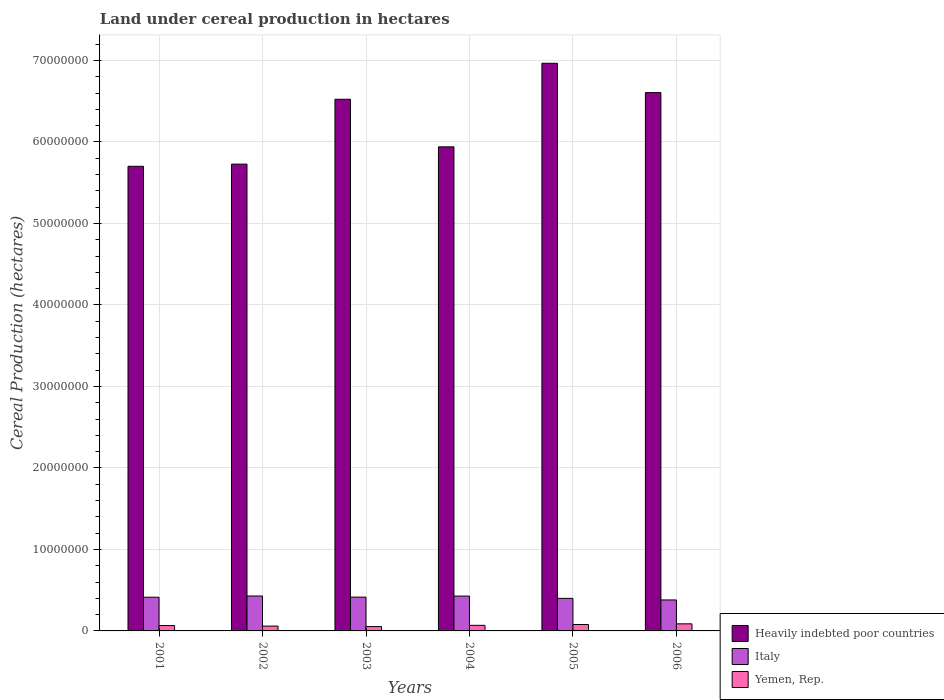How many different coloured bars are there?
Give a very brief answer. 3. What is the label of the 6th group of bars from the left?
Give a very brief answer. 2006. In how many cases, is the number of bars for a given year not equal to the number of legend labels?
Your response must be concise. 0. What is the land under cereal production in Italy in 2004?
Your answer should be compact. 4.28e+06. Across all years, what is the maximum land under cereal production in Italy?
Your response must be concise. 4.28e+06. Across all years, what is the minimum land under cereal production in Yemen, Rep.?
Offer a very short reply. 5.32e+05. What is the total land under cereal production in Italy in the graph?
Your answer should be very brief. 2.46e+07. What is the difference between the land under cereal production in Italy in 2002 and that in 2005?
Provide a succinct answer. 2.89e+05. What is the difference between the land under cereal production in Yemen, Rep. in 2001 and the land under cereal production in Heavily indebted poor countries in 2002?
Offer a terse response. -5.66e+07. What is the average land under cereal production in Yemen, Rep. per year?
Ensure brevity in your answer.  6.88e+05. In the year 2003, what is the difference between the land under cereal production in Yemen, Rep. and land under cereal production in Italy?
Your response must be concise. -3.62e+06. What is the ratio of the land under cereal production in Italy in 2001 to that in 2002?
Give a very brief answer. 0.96. What is the difference between the highest and the second highest land under cereal production in Yemen, Rep.?
Your response must be concise. 8.14e+04. What is the difference between the highest and the lowest land under cereal production in Italy?
Ensure brevity in your answer.  4.84e+05. In how many years, is the land under cereal production in Italy greater than the average land under cereal production in Italy taken over all years?
Your answer should be very brief. 4. How many bars are there?
Your response must be concise. 18. Are all the bars in the graph horizontal?
Keep it short and to the point. No. Does the graph contain grids?
Provide a short and direct response. Yes. How many legend labels are there?
Provide a short and direct response. 3. What is the title of the graph?
Provide a short and direct response. Land under cereal production in hectares. What is the label or title of the Y-axis?
Keep it short and to the point. Cereal Production (hectares). What is the Cereal Production (hectares) of Heavily indebted poor countries in 2001?
Ensure brevity in your answer.  5.70e+07. What is the Cereal Production (hectares) of Italy in 2001?
Your answer should be compact. 4.13e+06. What is the Cereal Production (hectares) of Yemen, Rep. in 2001?
Make the answer very short. 6.58e+05. What is the Cereal Production (hectares) in Heavily indebted poor countries in 2002?
Ensure brevity in your answer.  5.73e+07. What is the Cereal Production (hectares) of Italy in 2002?
Your response must be concise. 4.28e+06. What is the Cereal Production (hectares) of Yemen, Rep. in 2002?
Offer a very short reply. 5.93e+05. What is the Cereal Production (hectares) of Heavily indebted poor countries in 2003?
Your response must be concise. 6.52e+07. What is the Cereal Production (hectares) of Italy in 2003?
Make the answer very short. 4.15e+06. What is the Cereal Production (hectares) in Yemen, Rep. in 2003?
Offer a very short reply. 5.32e+05. What is the Cereal Production (hectares) in Heavily indebted poor countries in 2004?
Offer a terse response. 5.94e+07. What is the Cereal Production (hectares) of Italy in 2004?
Your response must be concise. 4.28e+06. What is the Cereal Production (hectares) in Yemen, Rep. in 2004?
Provide a short and direct response. 6.85e+05. What is the Cereal Production (hectares) in Heavily indebted poor countries in 2005?
Make the answer very short. 6.97e+07. What is the Cereal Production (hectares) of Italy in 2005?
Offer a very short reply. 4.00e+06. What is the Cereal Production (hectares) in Yemen, Rep. in 2005?
Provide a short and direct response. 7.88e+05. What is the Cereal Production (hectares) of Heavily indebted poor countries in 2006?
Offer a very short reply. 6.60e+07. What is the Cereal Production (hectares) in Italy in 2006?
Ensure brevity in your answer.  3.80e+06. What is the Cereal Production (hectares) in Yemen, Rep. in 2006?
Provide a succinct answer. 8.70e+05. Across all years, what is the maximum Cereal Production (hectares) in Heavily indebted poor countries?
Provide a short and direct response. 6.97e+07. Across all years, what is the maximum Cereal Production (hectares) in Italy?
Ensure brevity in your answer.  4.28e+06. Across all years, what is the maximum Cereal Production (hectares) in Yemen, Rep.?
Your response must be concise. 8.70e+05. Across all years, what is the minimum Cereal Production (hectares) in Heavily indebted poor countries?
Offer a very short reply. 5.70e+07. Across all years, what is the minimum Cereal Production (hectares) of Italy?
Offer a very short reply. 3.80e+06. Across all years, what is the minimum Cereal Production (hectares) of Yemen, Rep.?
Provide a succinct answer. 5.32e+05. What is the total Cereal Production (hectares) of Heavily indebted poor countries in the graph?
Keep it short and to the point. 3.75e+08. What is the total Cereal Production (hectares) of Italy in the graph?
Offer a very short reply. 2.46e+07. What is the total Cereal Production (hectares) of Yemen, Rep. in the graph?
Make the answer very short. 4.13e+06. What is the difference between the Cereal Production (hectares) in Heavily indebted poor countries in 2001 and that in 2002?
Provide a succinct answer. -2.68e+05. What is the difference between the Cereal Production (hectares) in Italy in 2001 and that in 2002?
Ensure brevity in your answer.  -1.50e+05. What is the difference between the Cereal Production (hectares) in Yemen, Rep. in 2001 and that in 2002?
Provide a short and direct response. 6.48e+04. What is the difference between the Cereal Production (hectares) of Heavily indebted poor countries in 2001 and that in 2003?
Keep it short and to the point. -8.23e+06. What is the difference between the Cereal Production (hectares) in Italy in 2001 and that in 2003?
Offer a terse response. -1.33e+04. What is the difference between the Cereal Production (hectares) of Yemen, Rep. in 2001 and that in 2003?
Provide a succinct answer. 1.26e+05. What is the difference between the Cereal Production (hectares) of Heavily indebted poor countries in 2001 and that in 2004?
Keep it short and to the point. -2.39e+06. What is the difference between the Cereal Production (hectares) of Italy in 2001 and that in 2004?
Ensure brevity in your answer.  -1.42e+05. What is the difference between the Cereal Production (hectares) in Yemen, Rep. in 2001 and that in 2004?
Provide a succinct answer. -2.76e+04. What is the difference between the Cereal Production (hectares) in Heavily indebted poor countries in 2001 and that in 2005?
Give a very brief answer. -1.26e+07. What is the difference between the Cereal Production (hectares) of Italy in 2001 and that in 2005?
Offer a terse response. 1.38e+05. What is the difference between the Cereal Production (hectares) of Yemen, Rep. in 2001 and that in 2005?
Ensure brevity in your answer.  -1.31e+05. What is the difference between the Cereal Production (hectares) of Heavily indebted poor countries in 2001 and that in 2006?
Your answer should be compact. -9.04e+06. What is the difference between the Cereal Production (hectares) in Italy in 2001 and that in 2006?
Your answer should be compact. 3.33e+05. What is the difference between the Cereal Production (hectares) in Yemen, Rep. in 2001 and that in 2006?
Offer a terse response. -2.12e+05. What is the difference between the Cereal Production (hectares) of Heavily indebted poor countries in 2002 and that in 2003?
Offer a terse response. -7.96e+06. What is the difference between the Cereal Production (hectares) in Italy in 2002 and that in 2003?
Your answer should be compact. 1.37e+05. What is the difference between the Cereal Production (hectares) in Yemen, Rep. in 2002 and that in 2003?
Your answer should be very brief. 6.08e+04. What is the difference between the Cereal Production (hectares) of Heavily indebted poor countries in 2002 and that in 2004?
Keep it short and to the point. -2.12e+06. What is the difference between the Cereal Production (hectares) in Italy in 2002 and that in 2004?
Ensure brevity in your answer.  8142. What is the difference between the Cereal Production (hectares) of Yemen, Rep. in 2002 and that in 2004?
Your answer should be compact. -9.24e+04. What is the difference between the Cereal Production (hectares) in Heavily indebted poor countries in 2002 and that in 2005?
Your answer should be very brief. -1.24e+07. What is the difference between the Cereal Production (hectares) in Italy in 2002 and that in 2005?
Provide a short and direct response. 2.89e+05. What is the difference between the Cereal Production (hectares) of Yemen, Rep. in 2002 and that in 2005?
Offer a very short reply. -1.95e+05. What is the difference between the Cereal Production (hectares) in Heavily indebted poor countries in 2002 and that in 2006?
Offer a terse response. -8.78e+06. What is the difference between the Cereal Production (hectares) in Italy in 2002 and that in 2006?
Offer a very short reply. 4.84e+05. What is the difference between the Cereal Production (hectares) of Yemen, Rep. in 2002 and that in 2006?
Provide a succinct answer. -2.77e+05. What is the difference between the Cereal Production (hectares) of Heavily indebted poor countries in 2003 and that in 2004?
Provide a succinct answer. 5.84e+06. What is the difference between the Cereal Production (hectares) of Italy in 2003 and that in 2004?
Give a very brief answer. -1.29e+05. What is the difference between the Cereal Production (hectares) of Yemen, Rep. in 2003 and that in 2004?
Ensure brevity in your answer.  -1.53e+05. What is the difference between the Cereal Production (hectares) in Heavily indebted poor countries in 2003 and that in 2005?
Provide a short and direct response. -4.42e+06. What is the difference between the Cereal Production (hectares) in Italy in 2003 and that in 2005?
Your response must be concise. 1.52e+05. What is the difference between the Cereal Production (hectares) in Yemen, Rep. in 2003 and that in 2005?
Provide a short and direct response. -2.56e+05. What is the difference between the Cereal Production (hectares) of Heavily indebted poor countries in 2003 and that in 2006?
Your answer should be very brief. -8.17e+05. What is the difference between the Cereal Production (hectares) in Italy in 2003 and that in 2006?
Make the answer very short. 3.47e+05. What is the difference between the Cereal Production (hectares) in Yemen, Rep. in 2003 and that in 2006?
Provide a succinct answer. -3.38e+05. What is the difference between the Cereal Production (hectares) of Heavily indebted poor countries in 2004 and that in 2005?
Give a very brief answer. -1.03e+07. What is the difference between the Cereal Production (hectares) in Italy in 2004 and that in 2005?
Keep it short and to the point. 2.81e+05. What is the difference between the Cereal Production (hectares) in Yemen, Rep. in 2004 and that in 2005?
Keep it short and to the point. -1.03e+05. What is the difference between the Cereal Production (hectares) of Heavily indebted poor countries in 2004 and that in 2006?
Your response must be concise. -6.65e+06. What is the difference between the Cereal Production (hectares) of Italy in 2004 and that in 2006?
Your answer should be very brief. 4.75e+05. What is the difference between the Cereal Production (hectares) in Yemen, Rep. in 2004 and that in 2006?
Ensure brevity in your answer.  -1.84e+05. What is the difference between the Cereal Production (hectares) in Heavily indebted poor countries in 2005 and that in 2006?
Make the answer very short. 3.60e+06. What is the difference between the Cereal Production (hectares) in Italy in 2005 and that in 2006?
Your answer should be compact. 1.95e+05. What is the difference between the Cereal Production (hectares) in Yemen, Rep. in 2005 and that in 2006?
Your response must be concise. -8.14e+04. What is the difference between the Cereal Production (hectares) of Heavily indebted poor countries in 2001 and the Cereal Production (hectares) of Italy in 2002?
Provide a short and direct response. 5.27e+07. What is the difference between the Cereal Production (hectares) of Heavily indebted poor countries in 2001 and the Cereal Production (hectares) of Yemen, Rep. in 2002?
Give a very brief answer. 5.64e+07. What is the difference between the Cereal Production (hectares) in Italy in 2001 and the Cereal Production (hectares) in Yemen, Rep. in 2002?
Give a very brief answer. 3.54e+06. What is the difference between the Cereal Production (hectares) of Heavily indebted poor countries in 2001 and the Cereal Production (hectares) of Italy in 2003?
Keep it short and to the point. 5.29e+07. What is the difference between the Cereal Production (hectares) in Heavily indebted poor countries in 2001 and the Cereal Production (hectares) in Yemen, Rep. in 2003?
Make the answer very short. 5.65e+07. What is the difference between the Cereal Production (hectares) in Italy in 2001 and the Cereal Production (hectares) in Yemen, Rep. in 2003?
Your response must be concise. 3.60e+06. What is the difference between the Cereal Production (hectares) in Heavily indebted poor countries in 2001 and the Cereal Production (hectares) in Italy in 2004?
Your answer should be very brief. 5.27e+07. What is the difference between the Cereal Production (hectares) of Heavily indebted poor countries in 2001 and the Cereal Production (hectares) of Yemen, Rep. in 2004?
Offer a very short reply. 5.63e+07. What is the difference between the Cereal Production (hectares) of Italy in 2001 and the Cereal Production (hectares) of Yemen, Rep. in 2004?
Provide a succinct answer. 3.45e+06. What is the difference between the Cereal Production (hectares) of Heavily indebted poor countries in 2001 and the Cereal Production (hectares) of Italy in 2005?
Make the answer very short. 5.30e+07. What is the difference between the Cereal Production (hectares) of Heavily indebted poor countries in 2001 and the Cereal Production (hectares) of Yemen, Rep. in 2005?
Offer a very short reply. 5.62e+07. What is the difference between the Cereal Production (hectares) in Italy in 2001 and the Cereal Production (hectares) in Yemen, Rep. in 2005?
Your answer should be very brief. 3.35e+06. What is the difference between the Cereal Production (hectares) in Heavily indebted poor countries in 2001 and the Cereal Production (hectares) in Italy in 2006?
Offer a terse response. 5.32e+07. What is the difference between the Cereal Production (hectares) in Heavily indebted poor countries in 2001 and the Cereal Production (hectares) in Yemen, Rep. in 2006?
Offer a terse response. 5.61e+07. What is the difference between the Cereal Production (hectares) in Italy in 2001 and the Cereal Production (hectares) in Yemen, Rep. in 2006?
Keep it short and to the point. 3.26e+06. What is the difference between the Cereal Production (hectares) in Heavily indebted poor countries in 2002 and the Cereal Production (hectares) in Italy in 2003?
Offer a terse response. 5.31e+07. What is the difference between the Cereal Production (hectares) of Heavily indebted poor countries in 2002 and the Cereal Production (hectares) of Yemen, Rep. in 2003?
Your response must be concise. 5.67e+07. What is the difference between the Cereal Production (hectares) of Italy in 2002 and the Cereal Production (hectares) of Yemen, Rep. in 2003?
Offer a very short reply. 3.75e+06. What is the difference between the Cereal Production (hectares) in Heavily indebted poor countries in 2002 and the Cereal Production (hectares) in Italy in 2004?
Provide a succinct answer. 5.30e+07. What is the difference between the Cereal Production (hectares) in Heavily indebted poor countries in 2002 and the Cereal Production (hectares) in Yemen, Rep. in 2004?
Your response must be concise. 5.66e+07. What is the difference between the Cereal Production (hectares) in Italy in 2002 and the Cereal Production (hectares) in Yemen, Rep. in 2004?
Your answer should be compact. 3.60e+06. What is the difference between the Cereal Production (hectares) of Heavily indebted poor countries in 2002 and the Cereal Production (hectares) of Italy in 2005?
Ensure brevity in your answer.  5.33e+07. What is the difference between the Cereal Production (hectares) of Heavily indebted poor countries in 2002 and the Cereal Production (hectares) of Yemen, Rep. in 2005?
Offer a very short reply. 5.65e+07. What is the difference between the Cereal Production (hectares) in Italy in 2002 and the Cereal Production (hectares) in Yemen, Rep. in 2005?
Your answer should be very brief. 3.50e+06. What is the difference between the Cereal Production (hectares) in Heavily indebted poor countries in 2002 and the Cereal Production (hectares) in Italy in 2006?
Give a very brief answer. 5.35e+07. What is the difference between the Cereal Production (hectares) in Heavily indebted poor countries in 2002 and the Cereal Production (hectares) in Yemen, Rep. in 2006?
Your response must be concise. 5.64e+07. What is the difference between the Cereal Production (hectares) in Italy in 2002 and the Cereal Production (hectares) in Yemen, Rep. in 2006?
Offer a very short reply. 3.41e+06. What is the difference between the Cereal Production (hectares) of Heavily indebted poor countries in 2003 and the Cereal Production (hectares) of Italy in 2004?
Provide a succinct answer. 6.10e+07. What is the difference between the Cereal Production (hectares) in Heavily indebted poor countries in 2003 and the Cereal Production (hectares) in Yemen, Rep. in 2004?
Provide a short and direct response. 6.45e+07. What is the difference between the Cereal Production (hectares) of Italy in 2003 and the Cereal Production (hectares) of Yemen, Rep. in 2004?
Keep it short and to the point. 3.46e+06. What is the difference between the Cereal Production (hectares) in Heavily indebted poor countries in 2003 and the Cereal Production (hectares) in Italy in 2005?
Provide a short and direct response. 6.12e+07. What is the difference between the Cereal Production (hectares) in Heavily indebted poor countries in 2003 and the Cereal Production (hectares) in Yemen, Rep. in 2005?
Make the answer very short. 6.44e+07. What is the difference between the Cereal Production (hectares) of Italy in 2003 and the Cereal Production (hectares) of Yemen, Rep. in 2005?
Offer a terse response. 3.36e+06. What is the difference between the Cereal Production (hectares) in Heavily indebted poor countries in 2003 and the Cereal Production (hectares) in Italy in 2006?
Your answer should be very brief. 6.14e+07. What is the difference between the Cereal Production (hectares) in Heavily indebted poor countries in 2003 and the Cereal Production (hectares) in Yemen, Rep. in 2006?
Give a very brief answer. 6.44e+07. What is the difference between the Cereal Production (hectares) in Italy in 2003 and the Cereal Production (hectares) in Yemen, Rep. in 2006?
Ensure brevity in your answer.  3.28e+06. What is the difference between the Cereal Production (hectares) of Heavily indebted poor countries in 2004 and the Cereal Production (hectares) of Italy in 2005?
Your response must be concise. 5.54e+07. What is the difference between the Cereal Production (hectares) in Heavily indebted poor countries in 2004 and the Cereal Production (hectares) in Yemen, Rep. in 2005?
Your answer should be compact. 5.86e+07. What is the difference between the Cereal Production (hectares) of Italy in 2004 and the Cereal Production (hectares) of Yemen, Rep. in 2005?
Keep it short and to the point. 3.49e+06. What is the difference between the Cereal Production (hectares) in Heavily indebted poor countries in 2004 and the Cereal Production (hectares) in Italy in 2006?
Provide a short and direct response. 5.56e+07. What is the difference between the Cereal Production (hectares) in Heavily indebted poor countries in 2004 and the Cereal Production (hectares) in Yemen, Rep. in 2006?
Keep it short and to the point. 5.85e+07. What is the difference between the Cereal Production (hectares) in Italy in 2004 and the Cereal Production (hectares) in Yemen, Rep. in 2006?
Provide a succinct answer. 3.41e+06. What is the difference between the Cereal Production (hectares) of Heavily indebted poor countries in 2005 and the Cereal Production (hectares) of Italy in 2006?
Keep it short and to the point. 6.58e+07. What is the difference between the Cereal Production (hectares) in Heavily indebted poor countries in 2005 and the Cereal Production (hectares) in Yemen, Rep. in 2006?
Your response must be concise. 6.88e+07. What is the difference between the Cereal Production (hectares) in Italy in 2005 and the Cereal Production (hectares) in Yemen, Rep. in 2006?
Offer a terse response. 3.13e+06. What is the average Cereal Production (hectares) of Heavily indebted poor countries per year?
Make the answer very short. 6.24e+07. What is the average Cereal Production (hectares) of Italy per year?
Keep it short and to the point. 4.11e+06. What is the average Cereal Production (hectares) of Yemen, Rep. per year?
Give a very brief answer. 6.88e+05. In the year 2001, what is the difference between the Cereal Production (hectares) in Heavily indebted poor countries and Cereal Production (hectares) in Italy?
Your answer should be compact. 5.29e+07. In the year 2001, what is the difference between the Cereal Production (hectares) in Heavily indebted poor countries and Cereal Production (hectares) in Yemen, Rep.?
Ensure brevity in your answer.  5.63e+07. In the year 2001, what is the difference between the Cereal Production (hectares) of Italy and Cereal Production (hectares) of Yemen, Rep.?
Make the answer very short. 3.48e+06. In the year 2002, what is the difference between the Cereal Production (hectares) of Heavily indebted poor countries and Cereal Production (hectares) of Italy?
Make the answer very short. 5.30e+07. In the year 2002, what is the difference between the Cereal Production (hectares) of Heavily indebted poor countries and Cereal Production (hectares) of Yemen, Rep.?
Offer a terse response. 5.67e+07. In the year 2002, what is the difference between the Cereal Production (hectares) in Italy and Cereal Production (hectares) in Yemen, Rep.?
Give a very brief answer. 3.69e+06. In the year 2003, what is the difference between the Cereal Production (hectares) in Heavily indebted poor countries and Cereal Production (hectares) in Italy?
Keep it short and to the point. 6.11e+07. In the year 2003, what is the difference between the Cereal Production (hectares) in Heavily indebted poor countries and Cereal Production (hectares) in Yemen, Rep.?
Give a very brief answer. 6.47e+07. In the year 2003, what is the difference between the Cereal Production (hectares) of Italy and Cereal Production (hectares) of Yemen, Rep.?
Your answer should be compact. 3.62e+06. In the year 2004, what is the difference between the Cereal Production (hectares) of Heavily indebted poor countries and Cereal Production (hectares) of Italy?
Your answer should be very brief. 5.51e+07. In the year 2004, what is the difference between the Cereal Production (hectares) of Heavily indebted poor countries and Cereal Production (hectares) of Yemen, Rep.?
Give a very brief answer. 5.87e+07. In the year 2004, what is the difference between the Cereal Production (hectares) of Italy and Cereal Production (hectares) of Yemen, Rep.?
Provide a succinct answer. 3.59e+06. In the year 2005, what is the difference between the Cereal Production (hectares) of Heavily indebted poor countries and Cereal Production (hectares) of Italy?
Your response must be concise. 6.57e+07. In the year 2005, what is the difference between the Cereal Production (hectares) of Heavily indebted poor countries and Cereal Production (hectares) of Yemen, Rep.?
Provide a short and direct response. 6.89e+07. In the year 2005, what is the difference between the Cereal Production (hectares) of Italy and Cereal Production (hectares) of Yemen, Rep.?
Provide a short and direct response. 3.21e+06. In the year 2006, what is the difference between the Cereal Production (hectares) of Heavily indebted poor countries and Cereal Production (hectares) of Italy?
Offer a very short reply. 6.22e+07. In the year 2006, what is the difference between the Cereal Production (hectares) in Heavily indebted poor countries and Cereal Production (hectares) in Yemen, Rep.?
Keep it short and to the point. 6.52e+07. In the year 2006, what is the difference between the Cereal Production (hectares) in Italy and Cereal Production (hectares) in Yemen, Rep.?
Make the answer very short. 2.93e+06. What is the ratio of the Cereal Production (hectares) of Italy in 2001 to that in 2002?
Your response must be concise. 0.96. What is the ratio of the Cereal Production (hectares) of Yemen, Rep. in 2001 to that in 2002?
Provide a short and direct response. 1.11. What is the ratio of the Cereal Production (hectares) in Heavily indebted poor countries in 2001 to that in 2003?
Your answer should be very brief. 0.87. What is the ratio of the Cereal Production (hectares) of Italy in 2001 to that in 2003?
Your response must be concise. 1. What is the ratio of the Cereal Production (hectares) of Yemen, Rep. in 2001 to that in 2003?
Provide a succinct answer. 1.24. What is the ratio of the Cereal Production (hectares) in Heavily indebted poor countries in 2001 to that in 2004?
Your response must be concise. 0.96. What is the ratio of the Cereal Production (hectares) of Italy in 2001 to that in 2004?
Give a very brief answer. 0.97. What is the ratio of the Cereal Production (hectares) in Yemen, Rep. in 2001 to that in 2004?
Give a very brief answer. 0.96. What is the ratio of the Cereal Production (hectares) in Heavily indebted poor countries in 2001 to that in 2005?
Your response must be concise. 0.82. What is the ratio of the Cereal Production (hectares) of Italy in 2001 to that in 2005?
Make the answer very short. 1.03. What is the ratio of the Cereal Production (hectares) of Yemen, Rep. in 2001 to that in 2005?
Keep it short and to the point. 0.83. What is the ratio of the Cereal Production (hectares) of Heavily indebted poor countries in 2001 to that in 2006?
Your response must be concise. 0.86. What is the ratio of the Cereal Production (hectares) in Italy in 2001 to that in 2006?
Your response must be concise. 1.09. What is the ratio of the Cereal Production (hectares) of Yemen, Rep. in 2001 to that in 2006?
Make the answer very short. 0.76. What is the ratio of the Cereal Production (hectares) in Heavily indebted poor countries in 2002 to that in 2003?
Make the answer very short. 0.88. What is the ratio of the Cereal Production (hectares) in Italy in 2002 to that in 2003?
Offer a very short reply. 1.03. What is the ratio of the Cereal Production (hectares) in Yemen, Rep. in 2002 to that in 2003?
Offer a terse response. 1.11. What is the ratio of the Cereal Production (hectares) in Heavily indebted poor countries in 2002 to that in 2004?
Ensure brevity in your answer.  0.96. What is the ratio of the Cereal Production (hectares) of Italy in 2002 to that in 2004?
Make the answer very short. 1. What is the ratio of the Cereal Production (hectares) in Yemen, Rep. in 2002 to that in 2004?
Provide a short and direct response. 0.87. What is the ratio of the Cereal Production (hectares) in Heavily indebted poor countries in 2002 to that in 2005?
Make the answer very short. 0.82. What is the ratio of the Cereal Production (hectares) in Italy in 2002 to that in 2005?
Ensure brevity in your answer.  1.07. What is the ratio of the Cereal Production (hectares) of Yemen, Rep. in 2002 to that in 2005?
Provide a succinct answer. 0.75. What is the ratio of the Cereal Production (hectares) in Heavily indebted poor countries in 2002 to that in 2006?
Provide a succinct answer. 0.87. What is the ratio of the Cereal Production (hectares) in Italy in 2002 to that in 2006?
Keep it short and to the point. 1.13. What is the ratio of the Cereal Production (hectares) of Yemen, Rep. in 2002 to that in 2006?
Make the answer very short. 0.68. What is the ratio of the Cereal Production (hectares) of Heavily indebted poor countries in 2003 to that in 2004?
Offer a very short reply. 1.1. What is the ratio of the Cereal Production (hectares) of Italy in 2003 to that in 2004?
Your answer should be compact. 0.97. What is the ratio of the Cereal Production (hectares) in Yemen, Rep. in 2003 to that in 2004?
Provide a succinct answer. 0.78. What is the ratio of the Cereal Production (hectares) of Heavily indebted poor countries in 2003 to that in 2005?
Keep it short and to the point. 0.94. What is the ratio of the Cereal Production (hectares) in Italy in 2003 to that in 2005?
Your response must be concise. 1.04. What is the ratio of the Cereal Production (hectares) in Yemen, Rep. in 2003 to that in 2005?
Make the answer very short. 0.68. What is the ratio of the Cereal Production (hectares) of Heavily indebted poor countries in 2003 to that in 2006?
Ensure brevity in your answer.  0.99. What is the ratio of the Cereal Production (hectares) of Italy in 2003 to that in 2006?
Provide a succinct answer. 1.09. What is the ratio of the Cereal Production (hectares) of Yemen, Rep. in 2003 to that in 2006?
Ensure brevity in your answer.  0.61. What is the ratio of the Cereal Production (hectares) in Heavily indebted poor countries in 2004 to that in 2005?
Give a very brief answer. 0.85. What is the ratio of the Cereal Production (hectares) of Italy in 2004 to that in 2005?
Offer a terse response. 1.07. What is the ratio of the Cereal Production (hectares) of Yemen, Rep. in 2004 to that in 2005?
Offer a terse response. 0.87. What is the ratio of the Cereal Production (hectares) of Heavily indebted poor countries in 2004 to that in 2006?
Make the answer very short. 0.9. What is the ratio of the Cereal Production (hectares) in Italy in 2004 to that in 2006?
Offer a terse response. 1.13. What is the ratio of the Cereal Production (hectares) in Yemen, Rep. in 2004 to that in 2006?
Your response must be concise. 0.79. What is the ratio of the Cereal Production (hectares) in Heavily indebted poor countries in 2005 to that in 2006?
Give a very brief answer. 1.05. What is the ratio of the Cereal Production (hectares) in Italy in 2005 to that in 2006?
Keep it short and to the point. 1.05. What is the ratio of the Cereal Production (hectares) in Yemen, Rep. in 2005 to that in 2006?
Ensure brevity in your answer.  0.91. What is the difference between the highest and the second highest Cereal Production (hectares) of Heavily indebted poor countries?
Offer a terse response. 3.60e+06. What is the difference between the highest and the second highest Cereal Production (hectares) of Italy?
Give a very brief answer. 8142. What is the difference between the highest and the second highest Cereal Production (hectares) of Yemen, Rep.?
Your response must be concise. 8.14e+04. What is the difference between the highest and the lowest Cereal Production (hectares) in Heavily indebted poor countries?
Your response must be concise. 1.26e+07. What is the difference between the highest and the lowest Cereal Production (hectares) of Italy?
Your response must be concise. 4.84e+05. What is the difference between the highest and the lowest Cereal Production (hectares) of Yemen, Rep.?
Keep it short and to the point. 3.38e+05. 